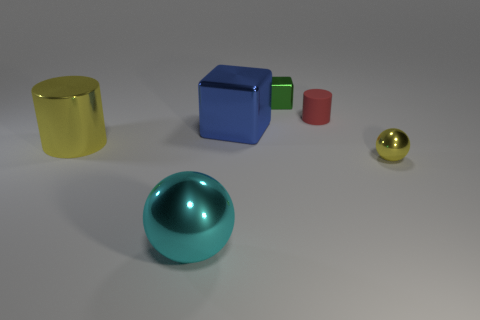Add 3 large yellow metal cylinders. How many objects exist? 9 Subtract all balls. How many objects are left? 4 Subtract all purple matte cylinders. Subtract all small yellow balls. How many objects are left? 5 Add 5 cyan shiny objects. How many cyan shiny objects are left? 6 Add 2 red matte cylinders. How many red matte cylinders exist? 3 Subtract 0 green cylinders. How many objects are left? 6 